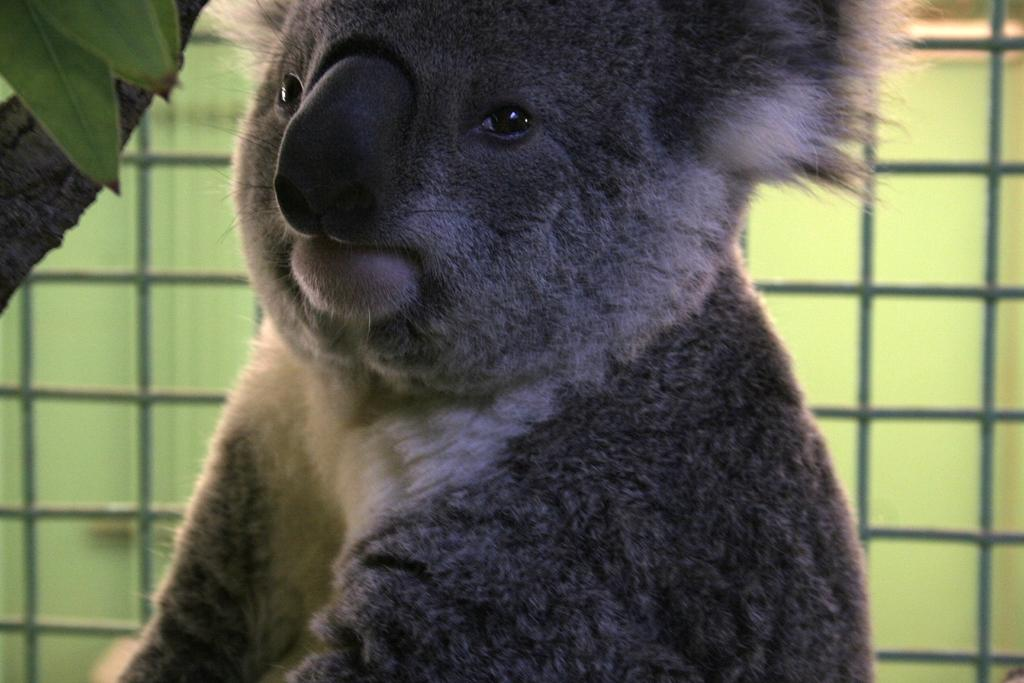What type of animal is in the image? The animal in the image resembles a koala. What color is the animal in the image? The animal is in black color. What is the opinion of the animal about the beds in the image? There are no beds present in the image, so it is not possible to determine the animal's opinion about them. 